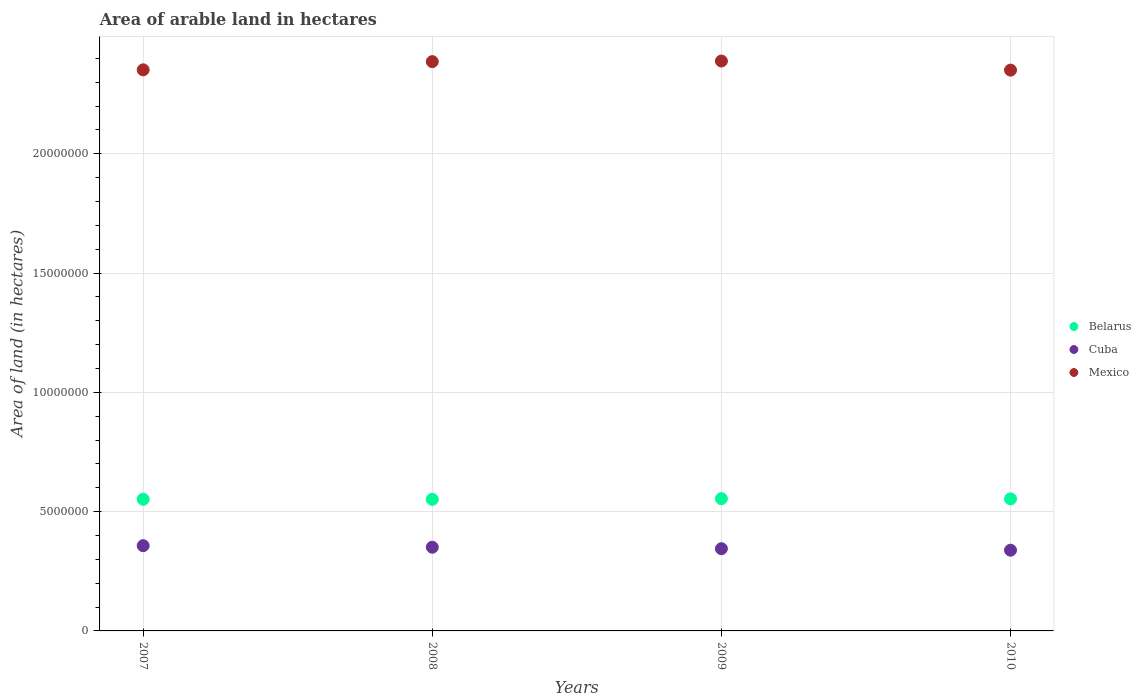Is the number of dotlines equal to the number of legend labels?
Give a very brief answer. Yes. What is the total arable land in Cuba in 2010?
Provide a short and direct response. 3.38e+06. Across all years, what is the maximum total arable land in Belarus?
Your answer should be very brief. 5.54e+06. Across all years, what is the minimum total arable land in Cuba?
Offer a terse response. 3.38e+06. What is the total total arable land in Belarus in the graph?
Offer a very short reply. 2.21e+07. What is the difference between the total arable land in Belarus in 2008 and that in 2010?
Keep it short and to the point. -1.90e+04. What is the difference between the total arable land in Mexico in 2008 and the total arable land in Belarus in 2010?
Your answer should be very brief. 1.83e+07. What is the average total arable land in Cuba per year?
Provide a short and direct response. 3.48e+06. In the year 2009, what is the difference between the total arable land in Cuba and total arable land in Mexico?
Ensure brevity in your answer.  -2.04e+07. What is the ratio of the total arable land in Cuba in 2007 to that in 2009?
Give a very brief answer. 1.04. What is the difference between the highest and the second highest total arable land in Mexico?
Ensure brevity in your answer.  2.50e+04. What is the difference between the highest and the lowest total arable land in Mexico?
Keep it short and to the point. 3.81e+05. In how many years, is the total arable land in Belarus greater than the average total arable land in Belarus taken over all years?
Give a very brief answer. 2. Is the sum of the total arable land in Belarus in 2007 and 2010 greater than the maximum total arable land in Mexico across all years?
Your answer should be very brief. No. Is it the case that in every year, the sum of the total arable land in Cuba and total arable land in Mexico  is greater than the total arable land in Belarus?
Keep it short and to the point. Yes. Is the total arable land in Belarus strictly less than the total arable land in Cuba over the years?
Keep it short and to the point. No. How many dotlines are there?
Your response must be concise. 3. What is the difference between two consecutive major ticks on the Y-axis?
Your answer should be compact. 5.00e+06. Does the graph contain any zero values?
Your answer should be very brief. No. How are the legend labels stacked?
Keep it short and to the point. Vertical. What is the title of the graph?
Your response must be concise. Area of arable land in hectares. What is the label or title of the Y-axis?
Offer a terse response. Area of land (in hectares). What is the Area of land (in hectares) of Belarus in 2007?
Provide a short and direct response. 5.52e+06. What is the Area of land (in hectares) in Cuba in 2007?
Make the answer very short. 3.57e+06. What is the Area of land (in hectares) in Mexico in 2007?
Keep it short and to the point. 2.35e+07. What is the Area of land (in hectares) of Belarus in 2008?
Your response must be concise. 5.52e+06. What is the Area of land (in hectares) of Cuba in 2008?
Provide a short and direct response. 3.51e+06. What is the Area of land (in hectares) in Mexico in 2008?
Offer a very short reply. 2.39e+07. What is the Area of land (in hectares) in Belarus in 2009?
Your answer should be very brief. 5.54e+06. What is the Area of land (in hectares) in Cuba in 2009?
Your response must be concise. 3.45e+06. What is the Area of land (in hectares) of Mexico in 2009?
Ensure brevity in your answer.  2.39e+07. What is the Area of land (in hectares) of Belarus in 2010?
Your answer should be compact. 5.54e+06. What is the Area of land (in hectares) in Cuba in 2010?
Your response must be concise. 3.38e+06. What is the Area of land (in hectares) in Mexico in 2010?
Offer a very short reply. 2.35e+07. Across all years, what is the maximum Area of land (in hectares) of Belarus?
Keep it short and to the point. 5.54e+06. Across all years, what is the maximum Area of land (in hectares) of Cuba?
Keep it short and to the point. 3.57e+06. Across all years, what is the maximum Area of land (in hectares) in Mexico?
Your response must be concise. 2.39e+07. Across all years, what is the minimum Area of land (in hectares) of Belarus?
Give a very brief answer. 5.52e+06. Across all years, what is the minimum Area of land (in hectares) in Cuba?
Offer a terse response. 3.38e+06. Across all years, what is the minimum Area of land (in hectares) in Mexico?
Give a very brief answer. 2.35e+07. What is the total Area of land (in hectares) of Belarus in the graph?
Provide a short and direct response. 2.21e+07. What is the total Area of land (in hectares) in Cuba in the graph?
Your answer should be very brief. 1.39e+07. What is the total Area of land (in hectares) in Mexico in the graph?
Your answer should be very brief. 9.48e+07. What is the difference between the Area of land (in hectares) in Belarus in 2007 and that in 2008?
Make the answer very short. 3000. What is the difference between the Area of land (in hectares) of Cuba in 2007 and that in 2008?
Provide a succinct answer. 6.44e+04. What is the difference between the Area of land (in hectares) of Mexico in 2007 and that in 2008?
Give a very brief answer. -3.44e+05. What is the difference between the Area of land (in hectares) of Belarus in 2007 and that in 2009?
Offer a terse response. -2.50e+04. What is the difference between the Area of land (in hectares) of Cuba in 2007 and that in 2009?
Make the answer very short. 1.27e+05. What is the difference between the Area of land (in hectares) of Mexico in 2007 and that in 2009?
Offer a terse response. -3.69e+05. What is the difference between the Area of land (in hectares) of Belarus in 2007 and that in 2010?
Keep it short and to the point. -1.60e+04. What is the difference between the Area of land (in hectares) in Cuba in 2007 and that in 2010?
Give a very brief answer. 1.89e+05. What is the difference between the Area of land (in hectares) in Mexico in 2007 and that in 2010?
Offer a terse response. 1.20e+04. What is the difference between the Area of land (in hectares) in Belarus in 2008 and that in 2009?
Your response must be concise. -2.80e+04. What is the difference between the Area of land (in hectares) in Cuba in 2008 and that in 2009?
Ensure brevity in your answer.  6.24e+04. What is the difference between the Area of land (in hectares) of Mexico in 2008 and that in 2009?
Make the answer very short. -2.50e+04. What is the difference between the Area of land (in hectares) in Belarus in 2008 and that in 2010?
Your response must be concise. -1.90e+04. What is the difference between the Area of land (in hectares) of Cuba in 2008 and that in 2010?
Give a very brief answer. 1.25e+05. What is the difference between the Area of land (in hectares) in Mexico in 2008 and that in 2010?
Provide a short and direct response. 3.56e+05. What is the difference between the Area of land (in hectares) in Belarus in 2009 and that in 2010?
Your answer should be very brief. 9000. What is the difference between the Area of land (in hectares) in Cuba in 2009 and that in 2010?
Offer a very short reply. 6.25e+04. What is the difference between the Area of land (in hectares) in Mexico in 2009 and that in 2010?
Your answer should be compact. 3.81e+05. What is the difference between the Area of land (in hectares) of Belarus in 2007 and the Area of land (in hectares) of Cuba in 2008?
Offer a terse response. 2.01e+06. What is the difference between the Area of land (in hectares) of Belarus in 2007 and the Area of land (in hectares) of Mexico in 2008?
Make the answer very short. -1.83e+07. What is the difference between the Area of land (in hectares) of Cuba in 2007 and the Area of land (in hectares) of Mexico in 2008?
Your response must be concise. -2.03e+07. What is the difference between the Area of land (in hectares) of Belarus in 2007 and the Area of land (in hectares) of Cuba in 2009?
Keep it short and to the point. 2.07e+06. What is the difference between the Area of land (in hectares) in Belarus in 2007 and the Area of land (in hectares) in Mexico in 2009?
Your answer should be compact. -1.84e+07. What is the difference between the Area of land (in hectares) of Cuba in 2007 and the Area of land (in hectares) of Mexico in 2009?
Offer a very short reply. -2.03e+07. What is the difference between the Area of land (in hectares) in Belarus in 2007 and the Area of land (in hectares) in Cuba in 2010?
Offer a terse response. 2.14e+06. What is the difference between the Area of land (in hectares) in Belarus in 2007 and the Area of land (in hectares) in Mexico in 2010?
Offer a very short reply. -1.80e+07. What is the difference between the Area of land (in hectares) in Cuba in 2007 and the Area of land (in hectares) in Mexico in 2010?
Your response must be concise. -1.99e+07. What is the difference between the Area of land (in hectares) in Belarus in 2008 and the Area of land (in hectares) in Cuba in 2009?
Provide a succinct answer. 2.07e+06. What is the difference between the Area of land (in hectares) in Belarus in 2008 and the Area of land (in hectares) in Mexico in 2009?
Your answer should be very brief. -1.84e+07. What is the difference between the Area of land (in hectares) in Cuba in 2008 and the Area of land (in hectares) in Mexico in 2009?
Make the answer very short. -2.04e+07. What is the difference between the Area of land (in hectares) in Belarus in 2008 and the Area of land (in hectares) in Cuba in 2010?
Offer a very short reply. 2.13e+06. What is the difference between the Area of land (in hectares) of Belarus in 2008 and the Area of land (in hectares) of Mexico in 2010?
Offer a very short reply. -1.80e+07. What is the difference between the Area of land (in hectares) in Cuba in 2008 and the Area of land (in hectares) in Mexico in 2010?
Ensure brevity in your answer.  -2.00e+07. What is the difference between the Area of land (in hectares) of Belarus in 2009 and the Area of land (in hectares) of Cuba in 2010?
Your response must be concise. 2.16e+06. What is the difference between the Area of land (in hectares) of Belarus in 2009 and the Area of land (in hectares) of Mexico in 2010?
Keep it short and to the point. -1.80e+07. What is the difference between the Area of land (in hectares) in Cuba in 2009 and the Area of land (in hectares) in Mexico in 2010?
Offer a terse response. -2.01e+07. What is the average Area of land (in hectares) of Belarus per year?
Your response must be concise. 5.53e+06. What is the average Area of land (in hectares) in Cuba per year?
Provide a succinct answer. 3.48e+06. What is the average Area of land (in hectares) in Mexico per year?
Make the answer very short. 2.37e+07. In the year 2007, what is the difference between the Area of land (in hectares) in Belarus and Area of land (in hectares) in Cuba?
Offer a terse response. 1.95e+06. In the year 2007, what is the difference between the Area of land (in hectares) in Belarus and Area of land (in hectares) in Mexico?
Keep it short and to the point. -1.80e+07. In the year 2007, what is the difference between the Area of land (in hectares) in Cuba and Area of land (in hectares) in Mexico?
Make the answer very short. -1.99e+07. In the year 2008, what is the difference between the Area of land (in hectares) of Belarus and Area of land (in hectares) of Cuba?
Your answer should be compact. 2.01e+06. In the year 2008, what is the difference between the Area of land (in hectares) in Belarus and Area of land (in hectares) in Mexico?
Make the answer very short. -1.83e+07. In the year 2008, what is the difference between the Area of land (in hectares) in Cuba and Area of land (in hectares) in Mexico?
Give a very brief answer. -2.04e+07. In the year 2009, what is the difference between the Area of land (in hectares) of Belarus and Area of land (in hectares) of Cuba?
Provide a short and direct response. 2.10e+06. In the year 2009, what is the difference between the Area of land (in hectares) in Belarus and Area of land (in hectares) in Mexico?
Provide a succinct answer. -1.83e+07. In the year 2009, what is the difference between the Area of land (in hectares) in Cuba and Area of land (in hectares) in Mexico?
Your response must be concise. -2.04e+07. In the year 2010, what is the difference between the Area of land (in hectares) in Belarus and Area of land (in hectares) in Cuba?
Give a very brief answer. 2.15e+06. In the year 2010, what is the difference between the Area of land (in hectares) in Belarus and Area of land (in hectares) in Mexico?
Offer a terse response. -1.80e+07. In the year 2010, what is the difference between the Area of land (in hectares) of Cuba and Area of land (in hectares) of Mexico?
Offer a very short reply. -2.01e+07. What is the ratio of the Area of land (in hectares) of Belarus in 2007 to that in 2008?
Your answer should be very brief. 1. What is the ratio of the Area of land (in hectares) of Cuba in 2007 to that in 2008?
Make the answer very short. 1.02. What is the ratio of the Area of land (in hectares) in Mexico in 2007 to that in 2008?
Provide a short and direct response. 0.99. What is the ratio of the Area of land (in hectares) of Cuba in 2007 to that in 2009?
Provide a succinct answer. 1.04. What is the ratio of the Area of land (in hectares) in Mexico in 2007 to that in 2009?
Ensure brevity in your answer.  0.98. What is the ratio of the Area of land (in hectares) of Cuba in 2007 to that in 2010?
Your answer should be compact. 1.06. What is the ratio of the Area of land (in hectares) of Belarus in 2008 to that in 2009?
Give a very brief answer. 0.99. What is the ratio of the Area of land (in hectares) in Cuba in 2008 to that in 2009?
Ensure brevity in your answer.  1.02. What is the ratio of the Area of land (in hectares) of Belarus in 2008 to that in 2010?
Offer a very short reply. 1. What is the ratio of the Area of land (in hectares) of Cuba in 2008 to that in 2010?
Keep it short and to the point. 1.04. What is the ratio of the Area of land (in hectares) in Mexico in 2008 to that in 2010?
Give a very brief answer. 1.02. What is the ratio of the Area of land (in hectares) of Belarus in 2009 to that in 2010?
Offer a very short reply. 1. What is the ratio of the Area of land (in hectares) in Cuba in 2009 to that in 2010?
Provide a short and direct response. 1.02. What is the ratio of the Area of land (in hectares) of Mexico in 2009 to that in 2010?
Your response must be concise. 1.02. What is the difference between the highest and the second highest Area of land (in hectares) of Belarus?
Offer a terse response. 9000. What is the difference between the highest and the second highest Area of land (in hectares) in Cuba?
Provide a short and direct response. 6.44e+04. What is the difference between the highest and the second highest Area of land (in hectares) in Mexico?
Give a very brief answer. 2.50e+04. What is the difference between the highest and the lowest Area of land (in hectares) in Belarus?
Your answer should be very brief. 2.80e+04. What is the difference between the highest and the lowest Area of land (in hectares) of Cuba?
Provide a short and direct response. 1.89e+05. What is the difference between the highest and the lowest Area of land (in hectares) in Mexico?
Ensure brevity in your answer.  3.81e+05. 